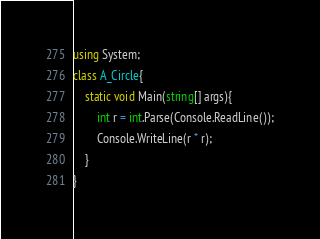<code> <loc_0><loc_0><loc_500><loc_500><_C#_>using System;
class A_Circle{
	static void Main(string[] args){
		int r = int.Parse(Console.ReadLine());
        Console.WriteLine(r * r);
	}
}</code> 